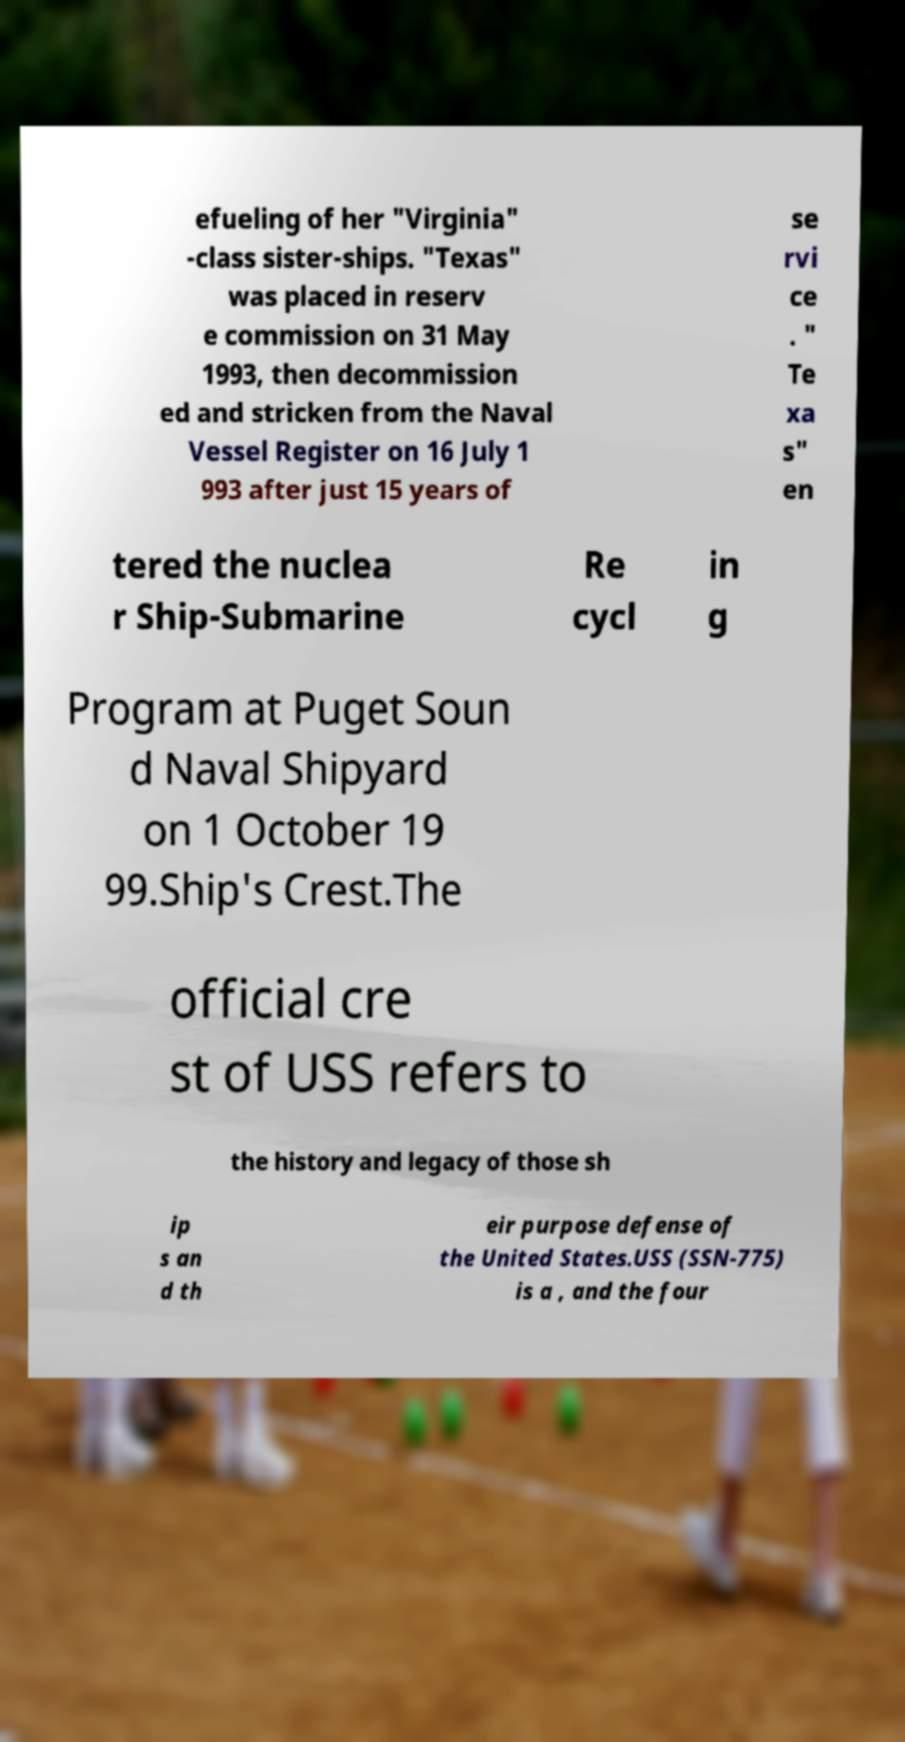Please read and relay the text visible in this image. What does it say? efueling of her "Virginia" -class sister-ships. "Texas" was placed in reserv e commission on 31 May 1993, then decommission ed and stricken from the Naval Vessel Register on 16 July 1 993 after just 15 years of se rvi ce . " Te xa s" en tered the nuclea r Ship-Submarine Re cycl in g Program at Puget Soun d Naval Shipyard on 1 October 19 99.Ship's Crest.The official cre st of USS refers to the history and legacy of those sh ip s an d th eir purpose defense of the United States.USS (SSN-775) is a , and the four 